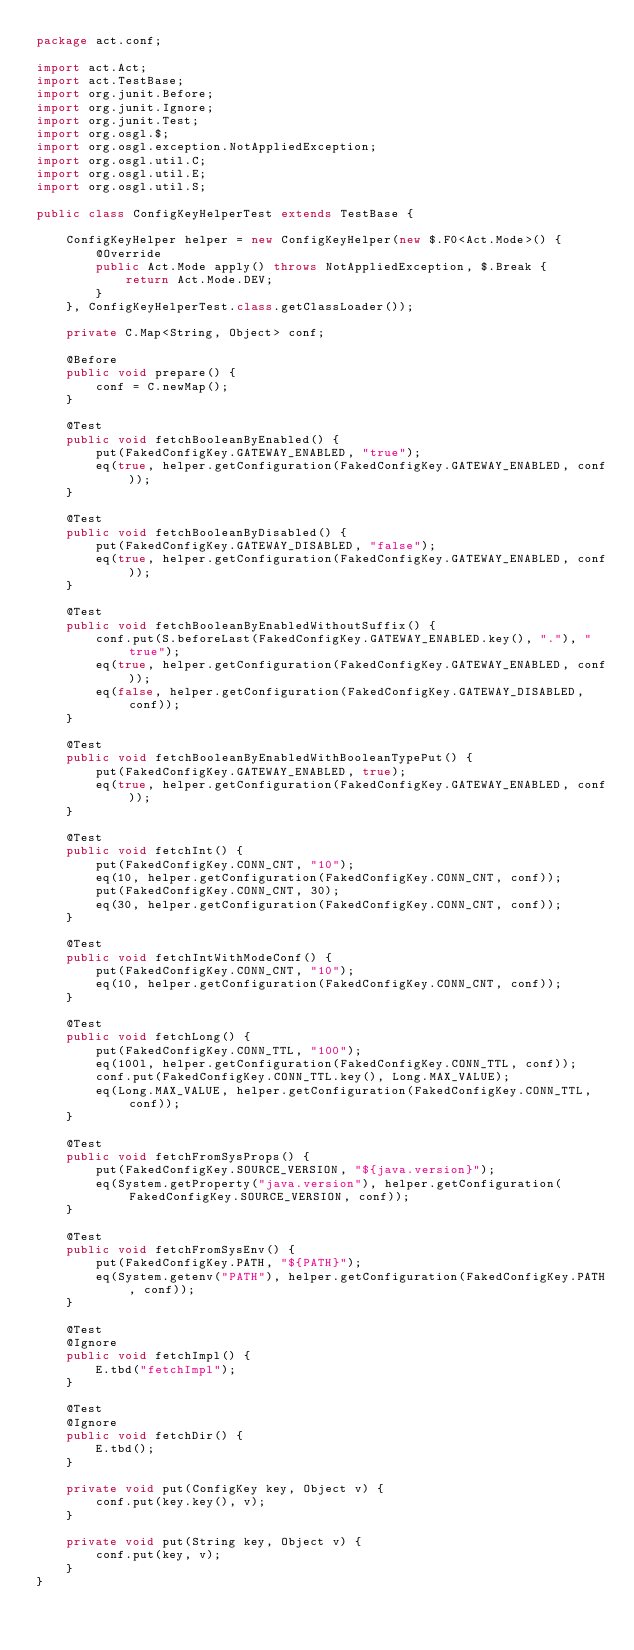<code> <loc_0><loc_0><loc_500><loc_500><_Java_>package act.conf;

import act.Act;
import act.TestBase;
import org.junit.Before;
import org.junit.Ignore;
import org.junit.Test;
import org.osgl.$;
import org.osgl.exception.NotAppliedException;
import org.osgl.util.C;
import org.osgl.util.E;
import org.osgl.util.S;

public class ConfigKeyHelperTest extends TestBase {

    ConfigKeyHelper helper = new ConfigKeyHelper(new $.F0<Act.Mode>() {
        @Override
        public Act.Mode apply() throws NotAppliedException, $.Break {
            return Act.Mode.DEV;
        }
    }, ConfigKeyHelperTest.class.getClassLoader());

    private C.Map<String, Object> conf;

    @Before
    public void prepare() {
        conf = C.newMap();
    }

    @Test
    public void fetchBooleanByEnabled() {
        put(FakedConfigKey.GATEWAY_ENABLED, "true");
        eq(true, helper.getConfiguration(FakedConfigKey.GATEWAY_ENABLED, conf));
    }

    @Test
    public void fetchBooleanByDisabled() {
        put(FakedConfigKey.GATEWAY_DISABLED, "false");
        eq(true, helper.getConfiguration(FakedConfigKey.GATEWAY_ENABLED, conf));
    }

    @Test
    public void fetchBooleanByEnabledWithoutSuffix() {
        conf.put(S.beforeLast(FakedConfigKey.GATEWAY_ENABLED.key(), "."), "true");
        eq(true, helper.getConfiguration(FakedConfigKey.GATEWAY_ENABLED, conf));
        eq(false, helper.getConfiguration(FakedConfigKey.GATEWAY_DISABLED, conf));
    }

    @Test
    public void fetchBooleanByEnabledWithBooleanTypePut() {
        put(FakedConfigKey.GATEWAY_ENABLED, true);
        eq(true, helper.getConfiguration(FakedConfigKey.GATEWAY_ENABLED, conf));
    }

    @Test
    public void fetchInt() {
        put(FakedConfigKey.CONN_CNT, "10");
        eq(10, helper.getConfiguration(FakedConfigKey.CONN_CNT, conf));
        put(FakedConfigKey.CONN_CNT, 30);
        eq(30, helper.getConfiguration(FakedConfigKey.CONN_CNT, conf));
    }

    @Test
    public void fetchIntWithModeConf() {
        put(FakedConfigKey.CONN_CNT, "10");
        eq(10, helper.getConfiguration(FakedConfigKey.CONN_CNT, conf));
    }

    @Test
    public void fetchLong() {
        put(FakedConfigKey.CONN_TTL, "100");
        eq(100l, helper.getConfiguration(FakedConfigKey.CONN_TTL, conf));
        conf.put(FakedConfigKey.CONN_TTL.key(), Long.MAX_VALUE);
        eq(Long.MAX_VALUE, helper.getConfiguration(FakedConfigKey.CONN_TTL, conf));
    }

    @Test
    public void fetchFromSysProps() {
        put(FakedConfigKey.SOURCE_VERSION, "${java.version}");
        eq(System.getProperty("java.version"), helper.getConfiguration(FakedConfigKey.SOURCE_VERSION, conf));
    }

    @Test
    public void fetchFromSysEnv() {
        put(FakedConfigKey.PATH, "${PATH}");
        eq(System.getenv("PATH"), helper.getConfiguration(FakedConfigKey.PATH, conf));
    }

    @Test
    @Ignore
    public void fetchImpl() {
        E.tbd("fetchImpl");
    }

    @Test
    @Ignore
    public void fetchDir() {
        E.tbd();
    }

    private void put(ConfigKey key, Object v) {
        conf.put(key.key(), v);
    }

    private void put(String key, Object v) {
        conf.put(key, v);
    }
}
</code> 